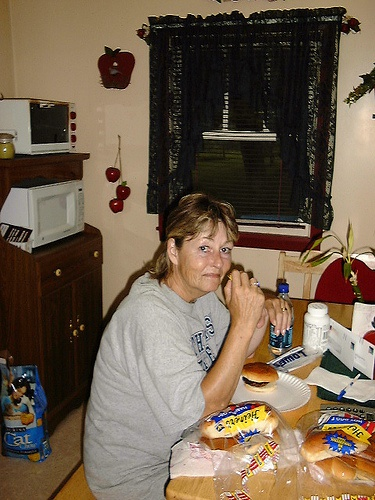Describe the objects in this image and their specific colors. I can see people in olive, darkgray, tan, and gray tones, dining table in olive, lightgray, darkgray, and tan tones, microwave in olive, darkgray, and gray tones, microwave in olive, black, darkgray, and gray tones, and potted plant in olive, tan, black, and maroon tones in this image. 